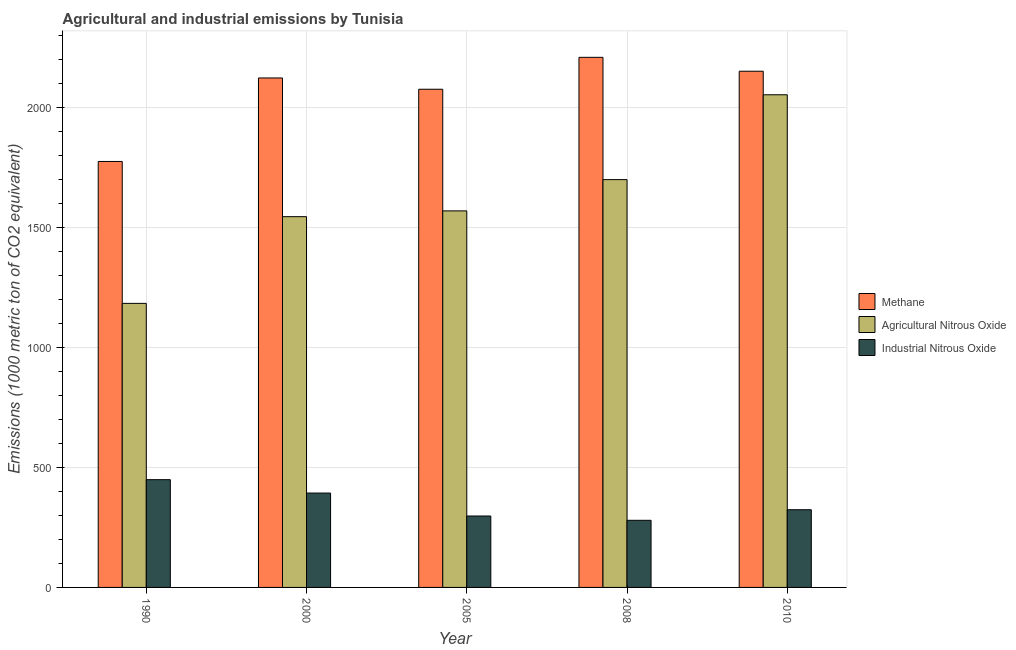How many different coloured bars are there?
Give a very brief answer. 3. What is the label of the 3rd group of bars from the left?
Provide a succinct answer. 2005. What is the amount of industrial nitrous oxide emissions in 2010?
Your answer should be compact. 323.9. Across all years, what is the maximum amount of agricultural nitrous oxide emissions?
Provide a succinct answer. 2053.7. Across all years, what is the minimum amount of methane emissions?
Your answer should be compact. 1775.7. In which year was the amount of methane emissions minimum?
Keep it short and to the point. 1990. What is the total amount of industrial nitrous oxide emissions in the graph?
Ensure brevity in your answer.  1744. What is the difference between the amount of methane emissions in 1990 and that in 2010?
Ensure brevity in your answer.  -376.2. What is the difference between the amount of industrial nitrous oxide emissions in 2000 and the amount of methane emissions in 2005?
Provide a succinct answer. 95.7. What is the average amount of industrial nitrous oxide emissions per year?
Offer a terse response. 348.8. In how many years, is the amount of methane emissions greater than 1100 metric ton?
Your answer should be very brief. 5. What is the ratio of the amount of methane emissions in 2000 to that in 2010?
Ensure brevity in your answer.  0.99. Is the difference between the amount of industrial nitrous oxide emissions in 1990 and 2008 greater than the difference between the amount of agricultural nitrous oxide emissions in 1990 and 2008?
Ensure brevity in your answer.  No. What is the difference between the highest and the second highest amount of agricultural nitrous oxide emissions?
Your answer should be very brief. 353.7. What is the difference between the highest and the lowest amount of agricultural nitrous oxide emissions?
Offer a terse response. 869.6. Is the sum of the amount of agricultural nitrous oxide emissions in 2005 and 2008 greater than the maximum amount of industrial nitrous oxide emissions across all years?
Give a very brief answer. Yes. What does the 2nd bar from the left in 2000 represents?
Make the answer very short. Agricultural Nitrous Oxide. What does the 3rd bar from the right in 1990 represents?
Provide a succinct answer. Methane. How many bars are there?
Offer a very short reply. 15. How many years are there in the graph?
Your answer should be compact. 5. What is the difference between two consecutive major ticks on the Y-axis?
Your response must be concise. 500. Does the graph contain any zero values?
Offer a terse response. No. Where does the legend appear in the graph?
Offer a very short reply. Center right. How many legend labels are there?
Provide a short and direct response. 3. What is the title of the graph?
Your response must be concise. Agricultural and industrial emissions by Tunisia. Does "Ages 20-50" appear as one of the legend labels in the graph?
Give a very brief answer. No. What is the label or title of the Y-axis?
Provide a short and direct response. Emissions (1000 metric ton of CO2 equivalent). What is the Emissions (1000 metric ton of CO2 equivalent) in Methane in 1990?
Provide a succinct answer. 1775.7. What is the Emissions (1000 metric ton of CO2 equivalent) of Agricultural Nitrous Oxide in 1990?
Your response must be concise. 1184.1. What is the Emissions (1000 metric ton of CO2 equivalent) of Industrial Nitrous Oxide in 1990?
Keep it short and to the point. 449.2. What is the Emissions (1000 metric ton of CO2 equivalent) in Methane in 2000?
Give a very brief answer. 2123.8. What is the Emissions (1000 metric ton of CO2 equivalent) in Agricultural Nitrous Oxide in 2000?
Your answer should be very brief. 1545.6. What is the Emissions (1000 metric ton of CO2 equivalent) in Industrial Nitrous Oxide in 2000?
Your response must be concise. 393.4. What is the Emissions (1000 metric ton of CO2 equivalent) in Methane in 2005?
Give a very brief answer. 2076.8. What is the Emissions (1000 metric ton of CO2 equivalent) of Agricultural Nitrous Oxide in 2005?
Your answer should be very brief. 1569.7. What is the Emissions (1000 metric ton of CO2 equivalent) of Industrial Nitrous Oxide in 2005?
Your answer should be compact. 297.7. What is the Emissions (1000 metric ton of CO2 equivalent) in Methane in 2008?
Offer a terse response. 2209.8. What is the Emissions (1000 metric ton of CO2 equivalent) in Agricultural Nitrous Oxide in 2008?
Offer a very short reply. 1700. What is the Emissions (1000 metric ton of CO2 equivalent) in Industrial Nitrous Oxide in 2008?
Offer a terse response. 279.8. What is the Emissions (1000 metric ton of CO2 equivalent) of Methane in 2010?
Keep it short and to the point. 2151.9. What is the Emissions (1000 metric ton of CO2 equivalent) of Agricultural Nitrous Oxide in 2010?
Ensure brevity in your answer.  2053.7. What is the Emissions (1000 metric ton of CO2 equivalent) of Industrial Nitrous Oxide in 2010?
Offer a terse response. 323.9. Across all years, what is the maximum Emissions (1000 metric ton of CO2 equivalent) in Methane?
Ensure brevity in your answer.  2209.8. Across all years, what is the maximum Emissions (1000 metric ton of CO2 equivalent) in Agricultural Nitrous Oxide?
Offer a very short reply. 2053.7. Across all years, what is the maximum Emissions (1000 metric ton of CO2 equivalent) of Industrial Nitrous Oxide?
Provide a succinct answer. 449.2. Across all years, what is the minimum Emissions (1000 metric ton of CO2 equivalent) of Methane?
Your answer should be very brief. 1775.7. Across all years, what is the minimum Emissions (1000 metric ton of CO2 equivalent) in Agricultural Nitrous Oxide?
Your response must be concise. 1184.1. Across all years, what is the minimum Emissions (1000 metric ton of CO2 equivalent) of Industrial Nitrous Oxide?
Provide a succinct answer. 279.8. What is the total Emissions (1000 metric ton of CO2 equivalent) in Methane in the graph?
Ensure brevity in your answer.  1.03e+04. What is the total Emissions (1000 metric ton of CO2 equivalent) in Agricultural Nitrous Oxide in the graph?
Offer a terse response. 8053.1. What is the total Emissions (1000 metric ton of CO2 equivalent) of Industrial Nitrous Oxide in the graph?
Keep it short and to the point. 1744. What is the difference between the Emissions (1000 metric ton of CO2 equivalent) in Methane in 1990 and that in 2000?
Your response must be concise. -348.1. What is the difference between the Emissions (1000 metric ton of CO2 equivalent) of Agricultural Nitrous Oxide in 1990 and that in 2000?
Offer a very short reply. -361.5. What is the difference between the Emissions (1000 metric ton of CO2 equivalent) in Industrial Nitrous Oxide in 1990 and that in 2000?
Provide a succinct answer. 55.8. What is the difference between the Emissions (1000 metric ton of CO2 equivalent) in Methane in 1990 and that in 2005?
Offer a terse response. -301.1. What is the difference between the Emissions (1000 metric ton of CO2 equivalent) in Agricultural Nitrous Oxide in 1990 and that in 2005?
Provide a succinct answer. -385.6. What is the difference between the Emissions (1000 metric ton of CO2 equivalent) of Industrial Nitrous Oxide in 1990 and that in 2005?
Your answer should be very brief. 151.5. What is the difference between the Emissions (1000 metric ton of CO2 equivalent) in Methane in 1990 and that in 2008?
Your response must be concise. -434.1. What is the difference between the Emissions (1000 metric ton of CO2 equivalent) of Agricultural Nitrous Oxide in 1990 and that in 2008?
Keep it short and to the point. -515.9. What is the difference between the Emissions (1000 metric ton of CO2 equivalent) in Industrial Nitrous Oxide in 1990 and that in 2008?
Your response must be concise. 169.4. What is the difference between the Emissions (1000 metric ton of CO2 equivalent) of Methane in 1990 and that in 2010?
Provide a short and direct response. -376.2. What is the difference between the Emissions (1000 metric ton of CO2 equivalent) of Agricultural Nitrous Oxide in 1990 and that in 2010?
Ensure brevity in your answer.  -869.6. What is the difference between the Emissions (1000 metric ton of CO2 equivalent) in Industrial Nitrous Oxide in 1990 and that in 2010?
Give a very brief answer. 125.3. What is the difference between the Emissions (1000 metric ton of CO2 equivalent) in Methane in 2000 and that in 2005?
Offer a very short reply. 47. What is the difference between the Emissions (1000 metric ton of CO2 equivalent) in Agricultural Nitrous Oxide in 2000 and that in 2005?
Your answer should be compact. -24.1. What is the difference between the Emissions (1000 metric ton of CO2 equivalent) of Industrial Nitrous Oxide in 2000 and that in 2005?
Your answer should be compact. 95.7. What is the difference between the Emissions (1000 metric ton of CO2 equivalent) in Methane in 2000 and that in 2008?
Your answer should be compact. -86. What is the difference between the Emissions (1000 metric ton of CO2 equivalent) of Agricultural Nitrous Oxide in 2000 and that in 2008?
Ensure brevity in your answer.  -154.4. What is the difference between the Emissions (1000 metric ton of CO2 equivalent) of Industrial Nitrous Oxide in 2000 and that in 2008?
Your answer should be compact. 113.6. What is the difference between the Emissions (1000 metric ton of CO2 equivalent) in Methane in 2000 and that in 2010?
Give a very brief answer. -28.1. What is the difference between the Emissions (1000 metric ton of CO2 equivalent) in Agricultural Nitrous Oxide in 2000 and that in 2010?
Ensure brevity in your answer.  -508.1. What is the difference between the Emissions (1000 metric ton of CO2 equivalent) in Industrial Nitrous Oxide in 2000 and that in 2010?
Your answer should be very brief. 69.5. What is the difference between the Emissions (1000 metric ton of CO2 equivalent) of Methane in 2005 and that in 2008?
Give a very brief answer. -133. What is the difference between the Emissions (1000 metric ton of CO2 equivalent) in Agricultural Nitrous Oxide in 2005 and that in 2008?
Offer a terse response. -130.3. What is the difference between the Emissions (1000 metric ton of CO2 equivalent) in Methane in 2005 and that in 2010?
Give a very brief answer. -75.1. What is the difference between the Emissions (1000 metric ton of CO2 equivalent) of Agricultural Nitrous Oxide in 2005 and that in 2010?
Your answer should be very brief. -484. What is the difference between the Emissions (1000 metric ton of CO2 equivalent) in Industrial Nitrous Oxide in 2005 and that in 2010?
Give a very brief answer. -26.2. What is the difference between the Emissions (1000 metric ton of CO2 equivalent) of Methane in 2008 and that in 2010?
Keep it short and to the point. 57.9. What is the difference between the Emissions (1000 metric ton of CO2 equivalent) of Agricultural Nitrous Oxide in 2008 and that in 2010?
Ensure brevity in your answer.  -353.7. What is the difference between the Emissions (1000 metric ton of CO2 equivalent) of Industrial Nitrous Oxide in 2008 and that in 2010?
Offer a very short reply. -44.1. What is the difference between the Emissions (1000 metric ton of CO2 equivalent) in Methane in 1990 and the Emissions (1000 metric ton of CO2 equivalent) in Agricultural Nitrous Oxide in 2000?
Your response must be concise. 230.1. What is the difference between the Emissions (1000 metric ton of CO2 equivalent) in Methane in 1990 and the Emissions (1000 metric ton of CO2 equivalent) in Industrial Nitrous Oxide in 2000?
Offer a terse response. 1382.3. What is the difference between the Emissions (1000 metric ton of CO2 equivalent) in Agricultural Nitrous Oxide in 1990 and the Emissions (1000 metric ton of CO2 equivalent) in Industrial Nitrous Oxide in 2000?
Keep it short and to the point. 790.7. What is the difference between the Emissions (1000 metric ton of CO2 equivalent) in Methane in 1990 and the Emissions (1000 metric ton of CO2 equivalent) in Agricultural Nitrous Oxide in 2005?
Your response must be concise. 206. What is the difference between the Emissions (1000 metric ton of CO2 equivalent) of Methane in 1990 and the Emissions (1000 metric ton of CO2 equivalent) of Industrial Nitrous Oxide in 2005?
Your answer should be very brief. 1478. What is the difference between the Emissions (1000 metric ton of CO2 equivalent) in Agricultural Nitrous Oxide in 1990 and the Emissions (1000 metric ton of CO2 equivalent) in Industrial Nitrous Oxide in 2005?
Make the answer very short. 886.4. What is the difference between the Emissions (1000 metric ton of CO2 equivalent) in Methane in 1990 and the Emissions (1000 metric ton of CO2 equivalent) in Agricultural Nitrous Oxide in 2008?
Ensure brevity in your answer.  75.7. What is the difference between the Emissions (1000 metric ton of CO2 equivalent) of Methane in 1990 and the Emissions (1000 metric ton of CO2 equivalent) of Industrial Nitrous Oxide in 2008?
Provide a succinct answer. 1495.9. What is the difference between the Emissions (1000 metric ton of CO2 equivalent) of Agricultural Nitrous Oxide in 1990 and the Emissions (1000 metric ton of CO2 equivalent) of Industrial Nitrous Oxide in 2008?
Give a very brief answer. 904.3. What is the difference between the Emissions (1000 metric ton of CO2 equivalent) of Methane in 1990 and the Emissions (1000 metric ton of CO2 equivalent) of Agricultural Nitrous Oxide in 2010?
Offer a very short reply. -278. What is the difference between the Emissions (1000 metric ton of CO2 equivalent) in Methane in 1990 and the Emissions (1000 metric ton of CO2 equivalent) in Industrial Nitrous Oxide in 2010?
Offer a very short reply. 1451.8. What is the difference between the Emissions (1000 metric ton of CO2 equivalent) in Agricultural Nitrous Oxide in 1990 and the Emissions (1000 metric ton of CO2 equivalent) in Industrial Nitrous Oxide in 2010?
Offer a terse response. 860.2. What is the difference between the Emissions (1000 metric ton of CO2 equivalent) in Methane in 2000 and the Emissions (1000 metric ton of CO2 equivalent) in Agricultural Nitrous Oxide in 2005?
Your answer should be compact. 554.1. What is the difference between the Emissions (1000 metric ton of CO2 equivalent) in Methane in 2000 and the Emissions (1000 metric ton of CO2 equivalent) in Industrial Nitrous Oxide in 2005?
Offer a terse response. 1826.1. What is the difference between the Emissions (1000 metric ton of CO2 equivalent) in Agricultural Nitrous Oxide in 2000 and the Emissions (1000 metric ton of CO2 equivalent) in Industrial Nitrous Oxide in 2005?
Ensure brevity in your answer.  1247.9. What is the difference between the Emissions (1000 metric ton of CO2 equivalent) of Methane in 2000 and the Emissions (1000 metric ton of CO2 equivalent) of Agricultural Nitrous Oxide in 2008?
Give a very brief answer. 423.8. What is the difference between the Emissions (1000 metric ton of CO2 equivalent) in Methane in 2000 and the Emissions (1000 metric ton of CO2 equivalent) in Industrial Nitrous Oxide in 2008?
Your answer should be very brief. 1844. What is the difference between the Emissions (1000 metric ton of CO2 equivalent) of Agricultural Nitrous Oxide in 2000 and the Emissions (1000 metric ton of CO2 equivalent) of Industrial Nitrous Oxide in 2008?
Provide a succinct answer. 1265.8. What is the difference between the Emissions (1000 metric ton of CO2 equivalent) in Methane in 2000 and the Emissions (1000 metric ton of CO2 equivalent) in Agricultural Nitrous Oxide in 2010?
Your answer should be compact. 70.1. What is the difference between the Emissions (1000 metric ton of CO2 equivalent) in Methane in 2000 and the Emissions (1000 metric ton of CO2 equivalent) in Industrial Nitrous Oxide in 2010?
Your answer should be very brief. 1799.9. What is the difference between the Emissions (1000 metric ton of CO2 equivalent) in Agricultural Nitrous Oxide in 2000 and the Emissions (1000 metric ton of CO2 equivalent) in Industrial Nitrous Oxide in 2010?
Make the answer very short. 1221.7. What is the difference between the Emissions (1000 metric ton of CO2 equivalent) of Methane in 2005 and the Emissions (1000 metric ton of CO2 equivalent) of Agricultural Nitrous Oxide in 2008?
Provide a short and direct response. 376.8. What is the difference between the Emissions (1000 metric ton of CO2 equivalent) in Methane in 2005 and the Emissions (1000 metric ton of CO2 equivalent) in Industrial Nitrous Oxide in 2008?
Your response must be concise. 1797. What is the difference between the Emissions (1000 metric ton of CO2 equivalent) in Agricultural Nitrous Oxide in 2005 and the Emissions (1000 metric ton of CO2 equivalent) in Industrial Nitrous Oxide in 2008?
Offer a terse response. 1289.9. What is the difference between the Emissions (1000 metric ton of CO2 equivalent) in Methane in 2005 and the Emissions (1000 metric ton of CO2 equivalent) in Agricultural Nitrous Oxide in 2010?
Provide a short and direct response. 23.1. What is the difference between the Emissions (1000 metric ton of CO2 equivalent) of Methane in 2005 and the Emissions (1000 metric ton of CO2 equivalent) of Industrial Nitrous Oxide in 2010?
Offer a very short reply. 1752.9. What is the difference between the Emissions (1000 metric ton of CO2 equivalent) in Agricultural Nitrous Oxide in 2005 and the Emissions (1000 metric ton of CO2 equivalent) in Industrial Nitrous Oxide in 2010?
Your response must be concise. 1245.8. What is the difference between the Emissions (1000 metric ton of CO2 equivalent) in Methane in 2008 and the Emissions (1000 metric ton of CO2 equivalent) in Agricultural Nitrous Oxide in 2010?
Make the answer very short. 156.1. What is the difference between the Emissions (1000 metric ton of CO2 equivalent) of Methane in 2008 and the Emissions (1000 metric ton of CO2 equivalent) of Industrial Nitrous Oxide in 2010?
Provide a short and direct response. 1885.9. What is the difference between the Emissions (1000 metric ton of CO2 equivalent) of Agricultural Nitrous Oxide in 2008 and the Emissions (1000 metric ton of CO2 equivalent) of Industrial Nitrous Oxide in 2010?
Ensure brevity in your answer.  1376.1. What is the average Emissions (1000 metric ton of CO2 equivalent) of Methane per year?
Ensure brevity in your answer.  2067.6. What is the average Emissions (1000 metric ton of CO2 equivalent) of Agricultural Nitrous Oxide per year?
Offer a very short reply. 1610.62. What is the average Emissions (1000 metric ton of CO2 equivalent) in Industrial Nitrous Oxide per year?
Keep it short and to the point. 348.8. In the year 1990, what is the difference between the Emissions (1000 metric ton of CO2 equivalent) of Methane and Emissions (1000 metric ton of CO2 equivalent) of Agricultural Nitrous Oxide?
Give a very brief answer. 591.6. In the year 1990, what is the difference between the Emissions (1000 metric ton of CO2 equivalent) of Methane and Emissions (1000 metric ton of CO2 equivalent) of Industrial Nitrous Oxide?
Keep it short and to the point. 1326.5. In the year 1990, what is the difference between the Emissions (1000 metric ton of CO2 equivalent) in Agricultural Nitrous Oxide and Emissions (1000 metric ton of CO2 equivalent) in Industrial Nitrous Oxide?
Give a very brief answer. 734.9. In the year 2000, what is the difference between the Emissions (1000 metric ton of CO2 equivalent) in Methane and Emissions (1000 metric ton of CO2 equivalent) in Agricultural Nitrous Oxide?
Your answer should be compact. 578.2. In the year 2000, what is the difference between the Emissions (1000 metric ton of CO2 equivalent) in Methane and Emissions (1000 metric ton of CO2 equivalent) in Industrial Nitrous Oxide?
Provide a short and direct response. 1730.4. In the year 2000, what is the difference between the Emissions (1000 metric ton of CO2 equivalent) of Agricultural Nitrous Oxide and Emissions (1000 metric ton of CO2 equivalent) of Industrial Nitrous Oxide?
Give a very brief answer. 1152.2. In the year 2005, what is the difference between the Emissions (1000 metric ton of CO2 equivalent) in Methane and Emissions (1000 metric ton of CO2 equivalent) in Agricultural Nitrous Oxide?
Make the answer very short. 507.1. In the year 2005, what is the difference between the Emissions (1000 metric ton of CO2 equivalent) in Methane and Emissions (1000 metric ton of CO2 equivalent) in Industrial Nitrous Oxide?
Offer a terse response. 1779.1. In the year 2005, what is the difference between the Emissions (1000 metric ton of CO2 equivalent) in Agricultural Nitrous Oxide and Emissions (1000 metric ton of CO2 equivalent) in Industrial Nitrous Oxide?
Provide a short and direct response. 1272. In the year 2008, what is the difference between the Emissions (1000 metric ton of CO2 equivalent) in Methane and Emissions (1000 metric ton of CO2 equivalent) in Agricultural Nitrous Oxide?
Ensure brevity in your answer.  509.8. In the year 2008, what is the difference between the Emissions (1000 metric ton of CO2 equivalent) of Methane and Emissions (1000 metric ton of CO2 equivalent) of Industrial Nitrous Oxide?
Provide a short and direct response. 1930. In the year 2008, what is the difference between the Emissions (1000 metric ton of CO2 equivalent) of Agricultural Nitrous Oxide and Emissions (1000 metric ton of CO2 equivalent) of Industrial Nitrous Oxide?
Keep it short and to the point. 1420.2. In the year 2010, what is the difference between the Emissions (1000 metric ton of CO2 equivalent) in Methane and Emissions (1000 metric ton of CO2 equivalent) in Agricultural Nitrous Oxide?
Ensure brevity in your answer.  98.2. In the year 2010, what is the difference between the Emissions (1000 metric ton of CO2 equivalent) of Methane and Emissions (1000 metric ton of CO2 equivalent) of Industrial Nitrous Oxide?
Your answer should be compact. 1828. In the year 2010, what is the difference between the Emissions (1000 metric ton of CO2 equivalent) in Agricultural Nitrous Oxide and Emissions (1000 metric ton of CO2 equivalent) in Industrial Nitrous Oxide?
Offer a very short reply. 1729.8. What is the ratio of the Emissions (1000 metric ton of CO2 equivalent) in Methane in 1990 to that in 2000?
Provide a succinct answer. 0.84. What is the ratio of the Emissions (1000 metric ton of CO2 equivalent) in Agricultural Nitrous Oxide in 1990 to that in 2000?
Offer a terse response. 0.77. What is the ratio of the Emissions (1000 metric ton of CO2 equivalent) in Industrial Nitrous Oxide in 1990 to that in 2000?
Your answer should be compact. 1.14. What is the ratio of the Emissions (1000 metric ton of CO2 equivalent) in Methane in 1990 to that in 2005?
Give a very brief answer. 0.85. What is the ratio of the Emissions (1000 metric ton of CO2 equivalent) of Agricultural Nitrous Oxide in 1990 to that in 2005?
Ensure brevity in your answer.  0.75. What is the ratio of the Emissions (1000 metric ton of CO2 equivalent) in Industrial Nitrous Oxide in 1990 to that in 2005?
Your answer should be very brief. 1.51. What is the ratio of the Emissions (1000 metric ton of CO2 equivalent) in Methane in 1990 to that in 2008?
Offer a terse response. 0.8. What is the ratio of the Emissions (1000 metric ton of CO2 equivalent) in Agricultural Nitrous Oxide in 1990 to that in 2008?
Your answer should be very brief. 0.7. What is the ratio of the Emissions (1000 metric ton of CO2 equivalent) in Industrial Nitrous Oxide in 1990 to that in 2008?
Offer a very short reply. 1.61. What is the ratio of the Emissions (1000 metric ton of CO2 equivalent) of Methane in 1990 to that in 2010?
Provide a short and direct response. 0.83. What is the ratio of the Emissions (1000 metric ton of CO2 equivalent) of Agricultural Nitrous Oxide in 1990 to that in 2010?
Your response must be concise. 0.58. What is the ratio of the Emissions (1000 metric ton of CO2 equivalent) of Industrial Nitrous Oxide in 1990 to that in 2010?
Give a very brief answer. 1.39. What is the ratio of the Emissions (1000 metric ton of CO2 equivalent) in Methane in 2000 to that in 2005?
Your answer should be very brief. 1.02. What is the ratio of the Emissions (1000 metric ton of CO2 equivalent) in Agricultural Nitrous Oxide in 2000 to that in 2005?
Your response must be concise. 0.98. What is the ratio of the Emissions (1000 metric ton of CO2 equivalent) in Industrial Nitrous Oxide in 2000 to that in 2005?
Offer a terse response. 1.32. What is the ratio of the Emissions (1000 metric ton of CO2 equivalent) in Methane in 2000 to that in 2008?
Provide a short and direct response. 0.96. What is the ratio of the Emissions (1000 metric ton of CO2 equivalent) in Agricultural Nitrous Oxide in 2000 to that in 2008?
Provide a short and direct response. 0.91. What is the ratio of the Emissions (1000 metric ton of CO2 equivalent) in Industrial Nitrous Oxide in 2000 to that in 2008?
Provide a short and direct response. 1.41. What is the ratio of the Emissions (1000 metric ton of CO2 equivalent) in Methane in 2000 to that in 2010?
Make the answer very short. 0.99. What is the ratio of the Emissions (1000 metric ton of CO2 equivalent) in Agricultural Nitrous Oxide in 2000 to that in 2010?
Your answer should be very brief. 0.75. What is the ratio of the Emissions (1000 metric ton of CO2 equivalent) in Industrial Nitrous Oxide in 2000 to that in 2010?
Give a very brief answer. 1.21. What is the ratio of the Emissions (1000 metric ton of CO2 equivalent) in Methane in 2005 to that in 2008?
Your response must be concise. 0.94. What is the ratio of the Emissions (1000 metric ton of CO2 equivalent) of Agricultural Nitrous Oxide in 2005 to that in 2008?
Offer a terse response. 0.92. What is the ratio of the Emissions (1000 metric ton of CO2 equivalent) of Industrial Nitrous Oxide in 2005 to that in 2008?
Give a very brief answer. 1.06. What is the ratio of the Emissions (1000 metric ton of CO2 equivalent) in Methane in 2005 to that in 2010?
Your answer should be very brief. 0.97. What is the ratio of the Emissions (1000 metric ton of CO2 equivalent) in Agricultural Nitrous Oxide in 2005 to that in 2010?
Keep it short and to the point. 0.76. What is the ratio of the Emissions (1000 metric ton of CO2 equivalent) in Industrial Nitrous Oxide in 2005 to that in 2010?
Keep it short and to the point. 0.92. What is the ratio of the Emissions (1000 metric ton of CO2 equivalent) of Methane in 2008 to that in 2010?
Provide a short and direct response. 1.03. What is the ratio of the Emissions (1000 metric ton of CO2 equivalent) of Agricultural Nitrous Oxide in 2008 to that in 2010?
Your answer should be very brief. 0.83. What is the ratio of the Emissions (1000 metric ton of CO2 equivalent) of Industrial Nitrous Oxide in 2008 to that in 2010?
Your response must be concise. 0.86. What is the difference between the highest and the second highest Emissions (1000 metric ton of CO2 equivalent) of Methane?
Your answer should be very brief. 57.9. What is the difference between the highest and the second highest Emissions (1000 metric ton of CO2 equivalent) in Agricultural Nitrous Oxide?
Your answer should be very brief. 353.7. What is the difference between the highest and the second highest Emissions (1000 metric ton of CO2 equivalent) in Industrial Nitrous Oxide?
Ensure brevity in your answer.  55.8. What is the difference between the highest and the lowest Emissions (1000 metric ton of CO2 equivalent) of Methane?
Keep it short and to the point. 434.1. What is the difference between the highest and the lowest Emissions (1000 metric ton of CO2 equivalent) of Agricultural Nitrous Oxide?
Make the answer very short. 869.6. What is the difference between the highest and the lowest Emissions (1000 metric ton of CO2 equivalent) of Industrial Nitrous Oxide?
Offer a very short reply. 169.4. 